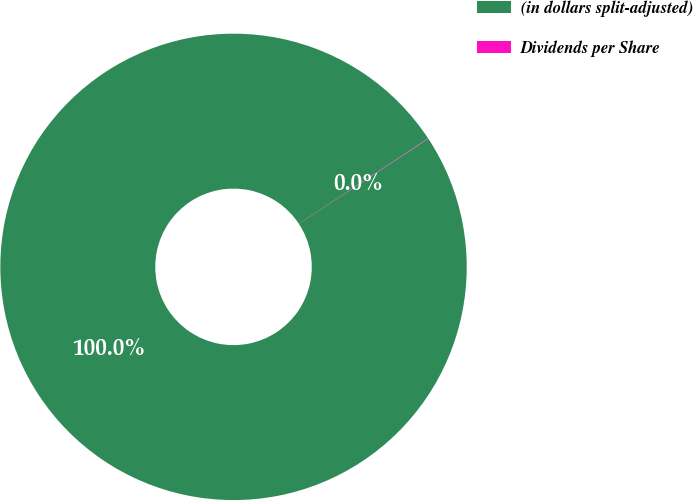<chart> <loc_0><loc_0><loc_500><loc_500><pie_chart><fcel>(in dollars split-adjusted)<fcel>Dividends per Share<nl><fcel>99.97%<fcel>0.03%<nl></chart> 